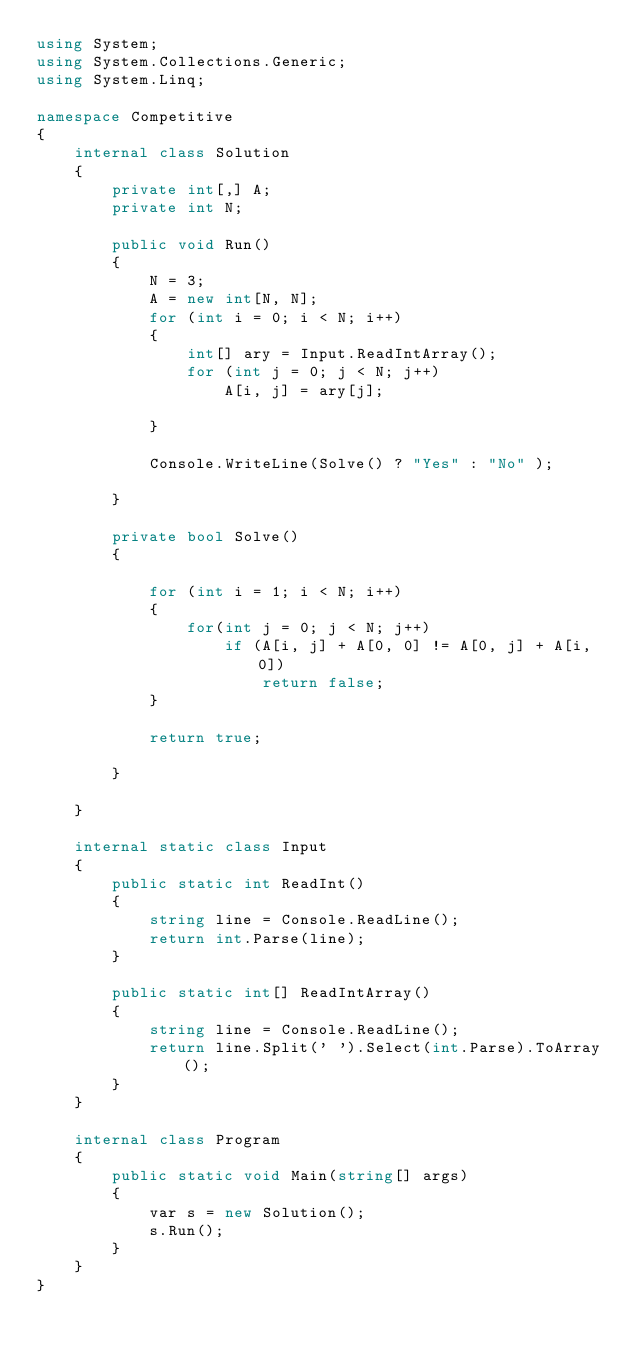<code> <loc_0><loc_0><loc_500><loc_500><_C#_>using System;
using System.Collections.Generic;
using System.Linq;

namespace Competitive
{
    internal class Solution
    {
        private int[,] A;
        private int N;
        
        public void Run()
        {
            N = 3;
            A = new int[N, N];
            for (int i = 0; i < N; i++)
            {
                int[] ary = Input.ReadIntArray();
                for (int j = 0; j < N; j++)
                    A[i, j] = ary[j];

            }

            Console.WriteLine(Solve() ? "Yes" : "No" );

        }

        private bool Solve()
        {
            
            for (int i = 1; i < N; i++)
            {
                for(int j = 0; j < N; j++)
                    if (A[i, j] + A[0, 0] != A[0, j] + A[i, 0])
                        return false;
            }

            return true;

        }

    }

    internal static class Input
    {
        public static int ReadInt()
        {
            string line = Console.ReadLine();
            return int.Parse(line);
        }

        public static int[] ReadIntArray()
        {
            string line = Console.ReadLine();
            return line.Split(' ').Select(int.Parse).ToArray();            
        }
    }

    internal class Program
    {
        public static void Main(string[] args)
        {
            var s = new Solution();
            s.Run();
        }
    }
}</code> 